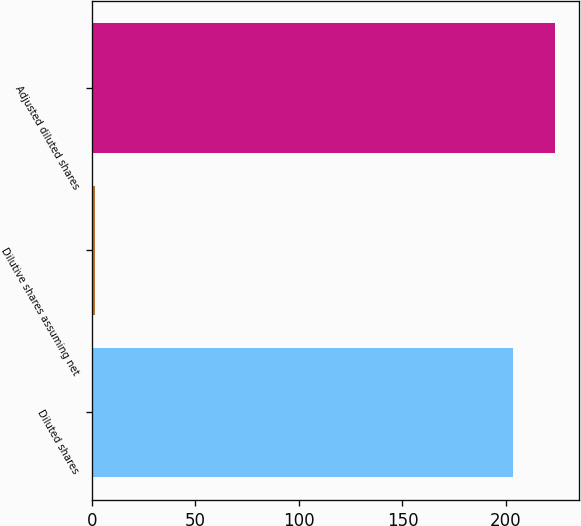Convert chart to OTSL. <chart><loc_0><loc_0><loc_500><loc_500><bar_chart><fcel>Diluted shares<fcel>Dilutive shares assuming net<fcel>Adjusted diluted shares<nl><fcel>203.5<fcel>1.5<fcel>223.85<nl></chart> 